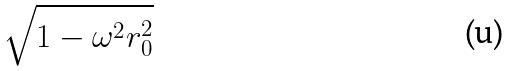Convert formula to latex. <formula><loc_0><loc_0><loc_500><loc_500>\sqrt { 1 - \omega ^ { 2 } r _ { 0 } ^ { 2 } }</formula> 